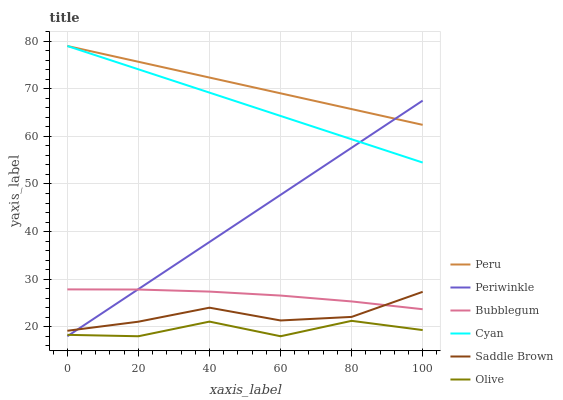Does Olive have the minimum area under the curve?
Answer yes or no. Yes. Does Peru have the maximum area under the curve?
Answer yes or no. Yes. Does Periwinkle have the minimum area under the curve?
Answer yes or no. No. Does Periwinkle have the maximum area under the curve?
Answer yes or no. No. Is Peru the smoothest?
Answer yes or no. Yes. Is Olive the roughest?
Answer yes or no. Yes. Is Periwinkle the smoothest?
Answer yes or no. No. Is Periwinkle the roughest?
Answer yes or no. No. Does Periwinkle have the lowest value?
Answer yes or no. Yes. Does Peru have the lowest value?
Answer yes or no. No. Does Cyan have the highest value?
Answer yes or no. Yes. Does Periwinkle have the highest value?
Answer yes or no. No. Is Olive less than Cyan?
Answer yes or no. Yes. Is Cyan greater than Olive?
Answer yes or no. Yes. Does Olive intersect Periwinkle?
Answer yes or no. Yes. Is Olive less than Periwinkle?
Answer yes or no. No. Is Olive greater than Periwinkle?
Answer yes or no. No. Does Olive intersect Cyan?
Answer yes or no. No. 